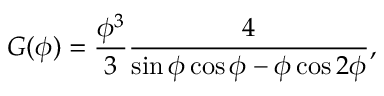Convert formula to latex. <formula><loc_0><loc_0><loc_500><loc_500>G ( \phi ) = \frac { \phi ^ { 3 } } { 3 } \frac { 4 } { \sin \phi \cos \phi - \phi \cos 2 \phi } ,</formula> 